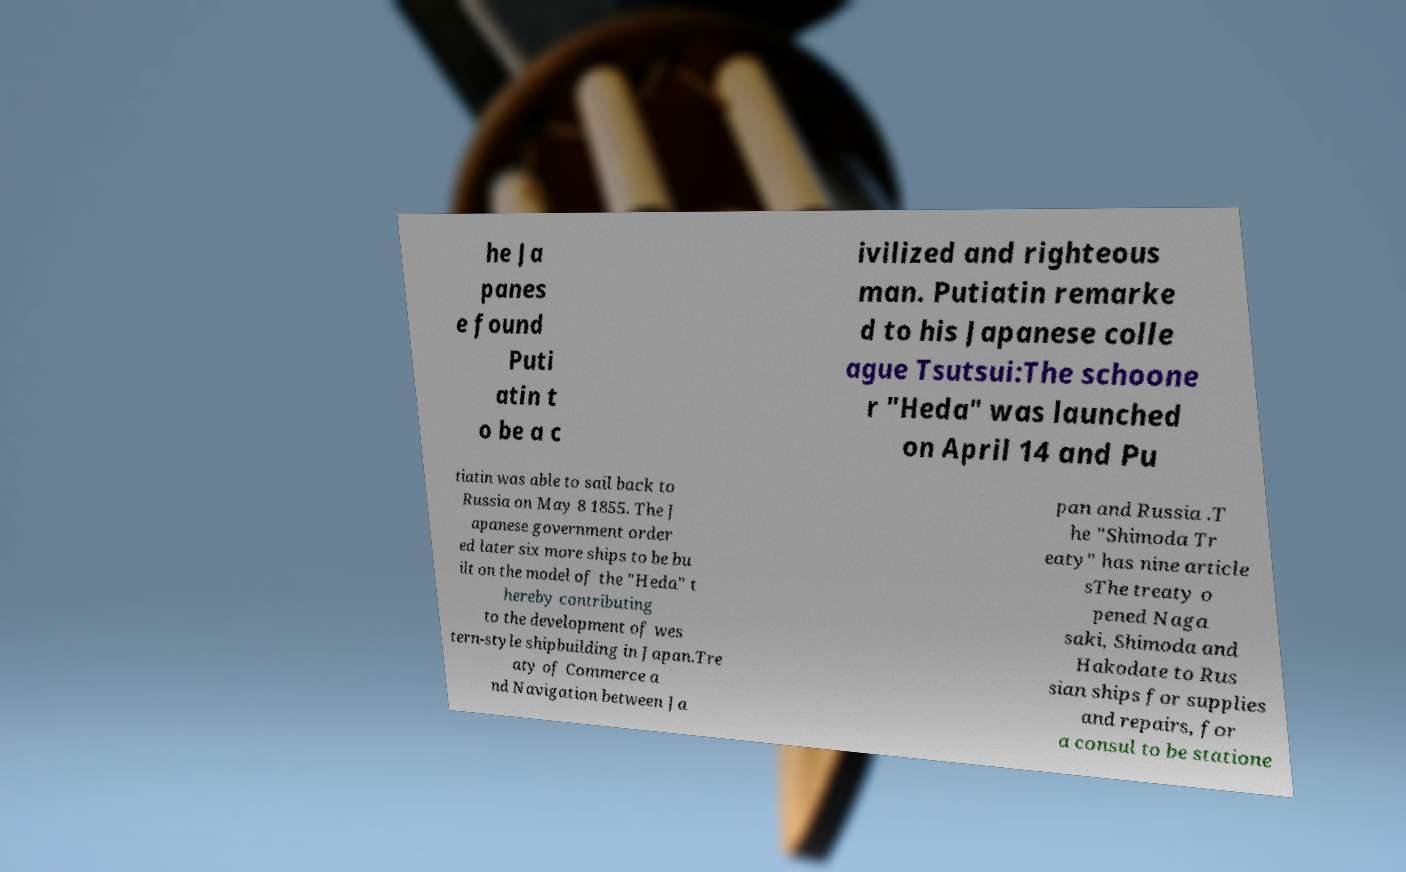Can you read and provide the text displayed in the image?This photo seems to have some interesting text. Can you extract and type it out for me? he Ja panes e found Puti atin t o be a c ivilized and righteous man. Putiatin remarke d to his Japanese colle ague Tsutsui:The schoone r "Heda" was launched on April 14 and Pu tiatin was able to sail back to Russia on May 8 1855. The J apanese government order ed later six more ships to be bu ilt on the model of the "Heda" t hereby contributing to the development of wes tern-style shipbuilding in Japan.Tre aty of Commerce a nd Navigation between Ja pan and Russia .T he "Shimoda Tr eaty" has nine article sThe treaty o pened Naga saki, Shimoda and Hakodate to Rus sian ships for supplies and repairs, for a consul to be statione 